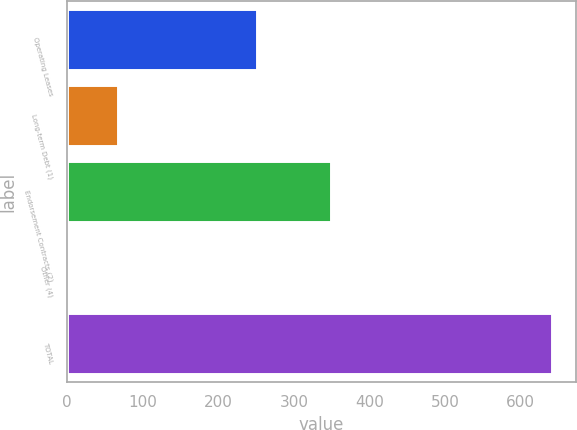<chart> <loc_0><loc_0><loc_500><loc_500><bar_chart><fcel>Operating Leases<fcel>Long-term Debt (1)<fcel>Endorsement Contracts (2)<fcel>Other (4)<fcel>TOTAL<nl><fcel>251<fcel>66.8<fcel>349<fcel>3<fcel>641<nl></chart> 